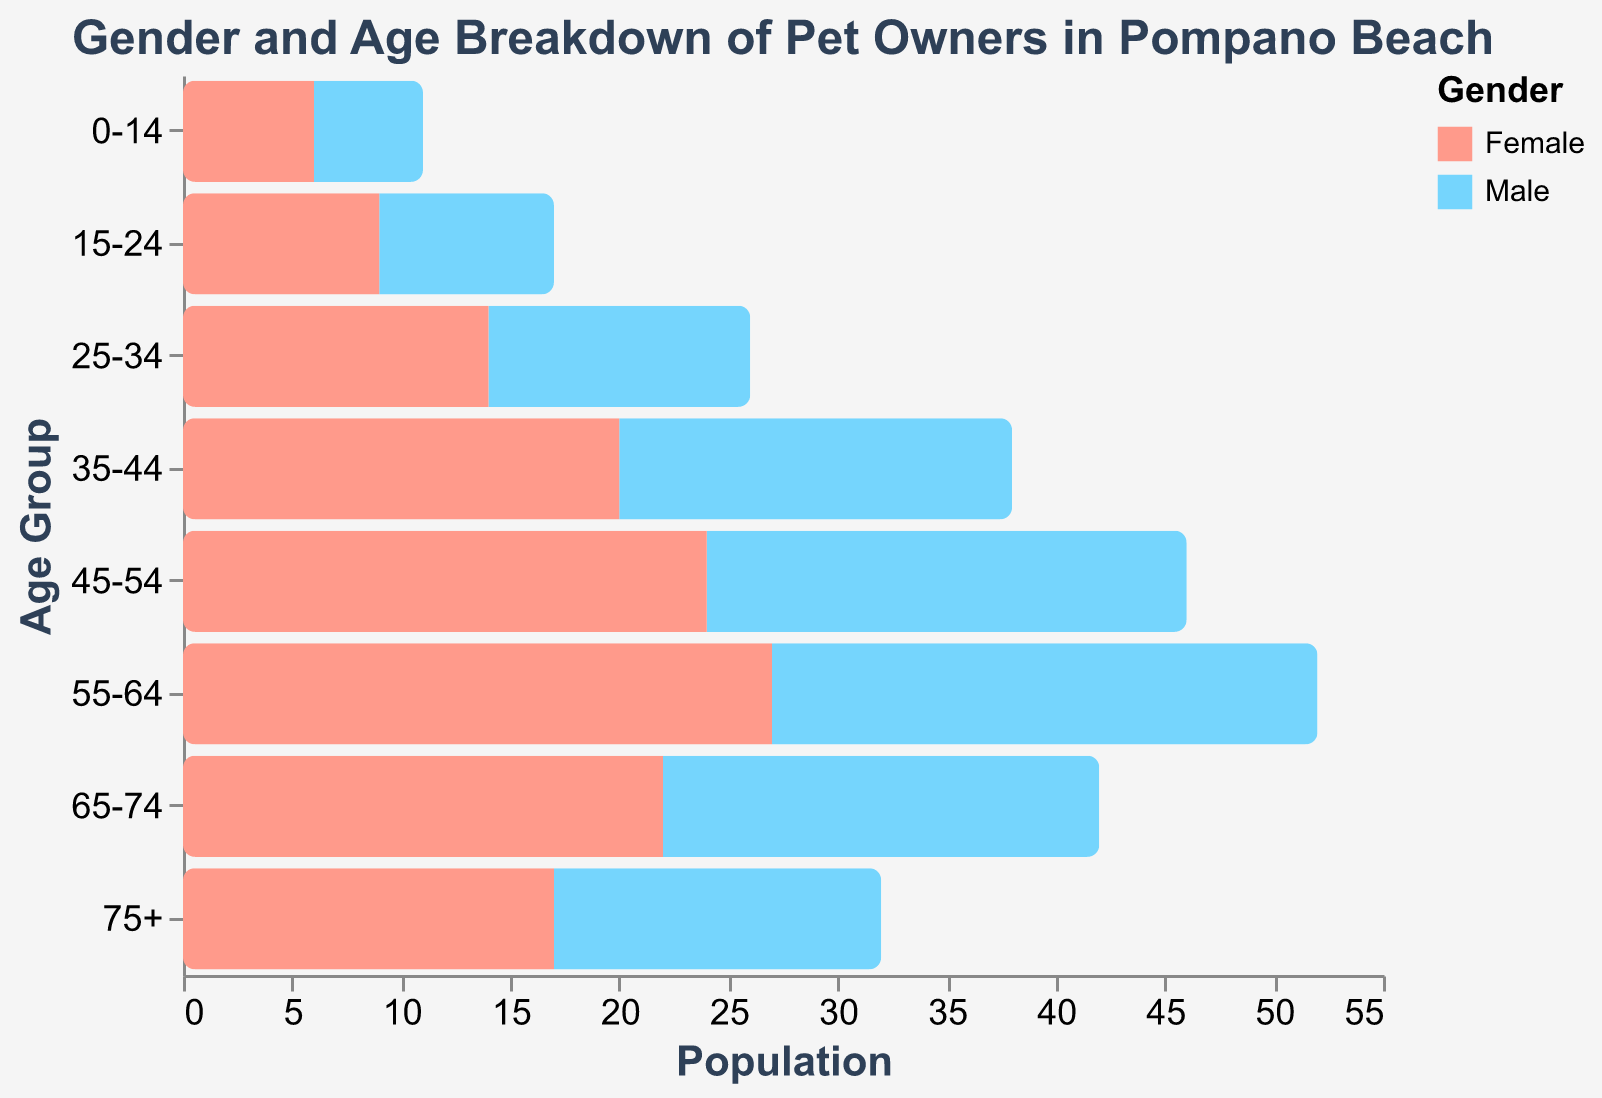What is the age group with the highest number of female pet owners? The figure shows various age groups on the y-axis and the number of male and female pet owners on the x-axis. The bar for each age group represents the corresponding number of pet owners. The age group with the longest bar for females is 55-64.
Answer: 55-64 How many more female pet owners are there in the 35-44 age group compared to males? The figure shows the number of female pet owners in the 35-44 age group is 20 and the number of male pet owners is 18 (ignoring the sign). The difference is 20 - 18 = 2.
Answer: 2 Are there more male or female pet owners in the 25-34 age group? The figure shows the number of male pet owners in the 25-34 age group is 12 (ignoring the sign) and the number of female pet owners is 14. Since 14 > 12, there are more female pet owners.
Answer: Female What is the total number of pet owners in the 0-14 age group? The figure shows the number of male pet owners in the 0-14 age group is 5 (ignoring the sign) and the number of female pet owners is 6. The total is 5 + 6 = 11.
Answer: 11 Which age group sees a decrease in both male and female pet ownership? By visually inspecting the bars, all age groups show pet ownership numbers, so none of the age groups represent a decrease, as each bar is positive.
Answer: None What is the average number of male and female pet owners across all age groups? To find the average, sum up all the values for males and females separately and divide by the number of age groups (8). For males: (-5) + (-8) + (-12) + (-18) + (-22) + (-25) + (-20) + (-15) = -125. For females: 6 + 9 + 14 + 20 + 24 + 27 + 22 + 17 = 139. Average for males = 125/8 = 15.625. Average for females = 139/8 = 17.375.
Answer: 15.625 (Male), 17.375 (Female) Which age group has the widest gender disparity in pet ownership? The widest gender disparity is indicated by the largest difference between the length of the male and female bars. The age group 55-64 has 27 (female) - 25 (male) = 2. This is the largest gap.
Answer: 55-64 How many more female pet owners are there in the 15-24 age group compared to the 75+ age group? The number of female pet owners in the 15-24 age group is 9, and in the 75+ age group is 17. The difference is 17 - 9 = 8.
Answer: 8 